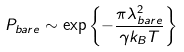Convert formula to latex. <formula><loc_0><loc_0><loc_500><loc_500>P _ { b a r e } \sim \exp \left \{ - \frac { \pi \lambda _ { b a r e } ^ { 2 } } { \gamma k _ { B } T } \right \}</formula> 